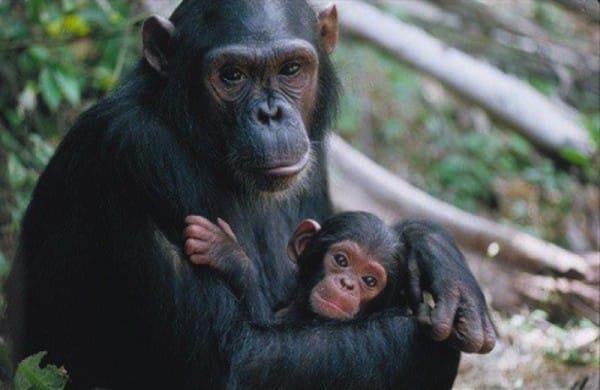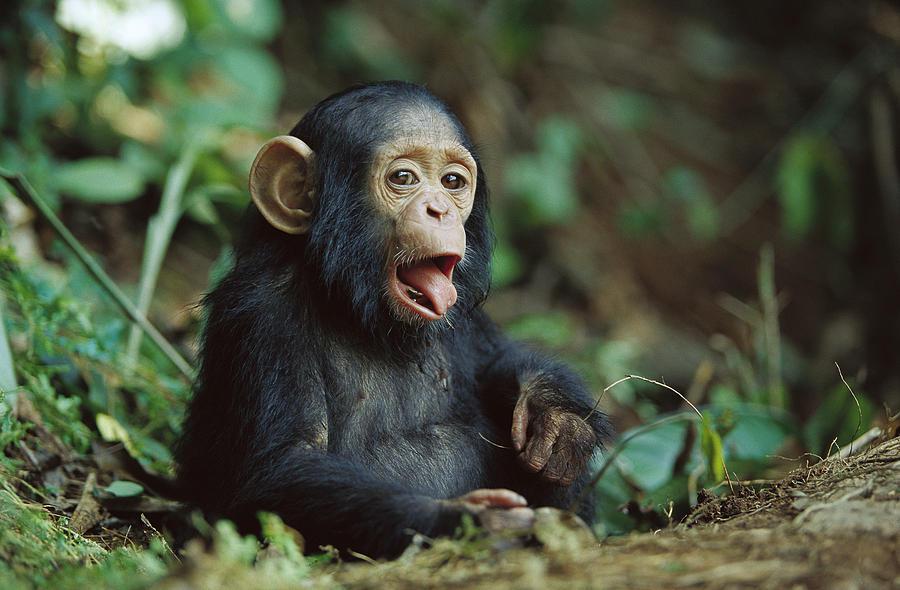The first image is the image on the left, the second image is the image on the right. Evaluate the accuracy of this statement regarding the images: "An image contains a human interacting with a chimpanzee.". Is it true? Answer yes or no. No. The first image is the image on the left, the second image is the image on the right. Given the left and right images, does the statement "In one image, a person is interacting with a chimpanzee, while a second image shows a chimp sitting with its knees drawn up and arms resting on them." hold true? Answer yes or no. No. 